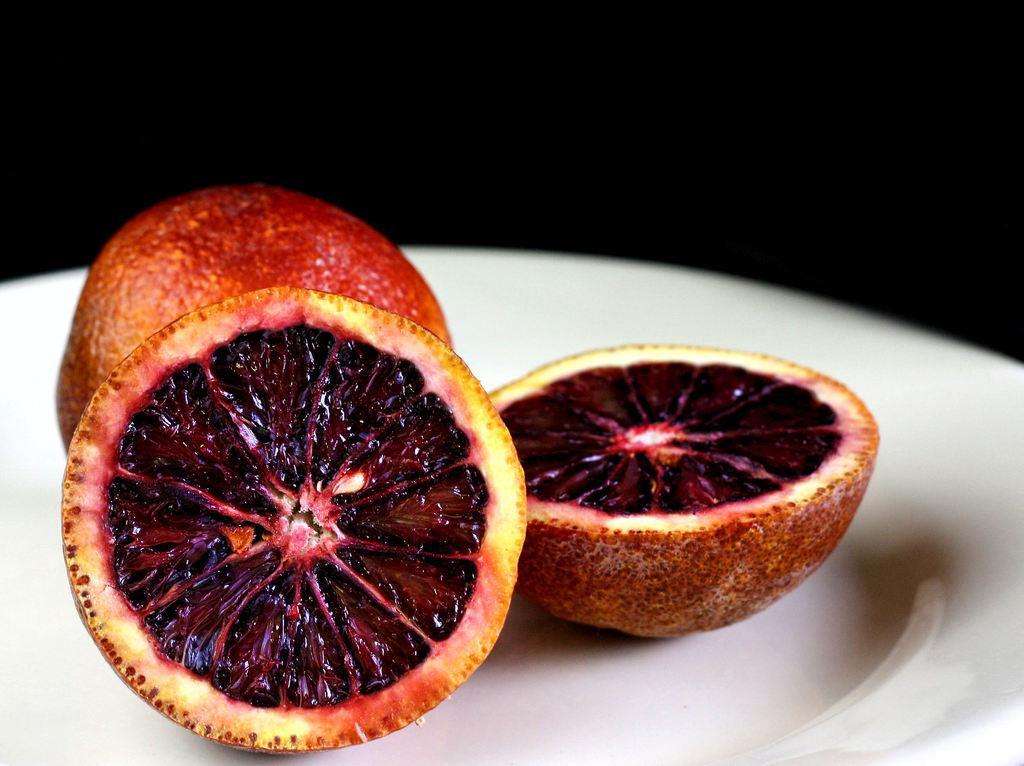How would you summarize this image in a sentence or two? In this image there is a fruit and two slices of a fruit are on the plate. Background is black in colour. 